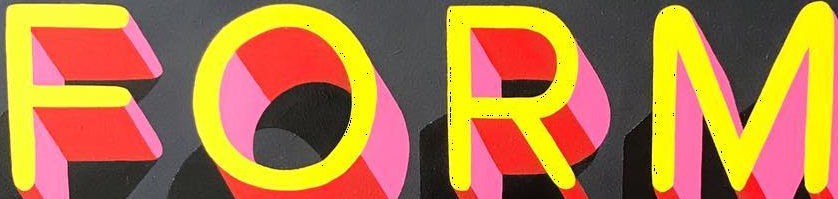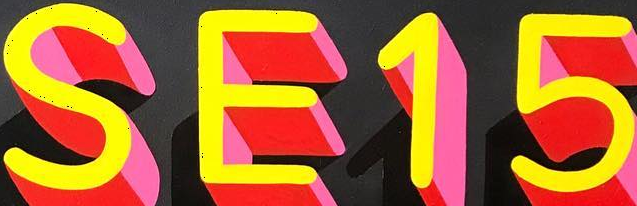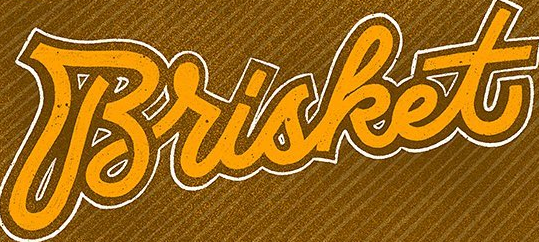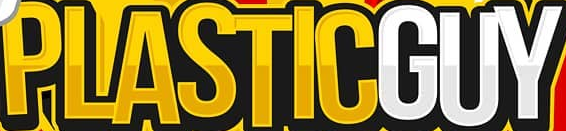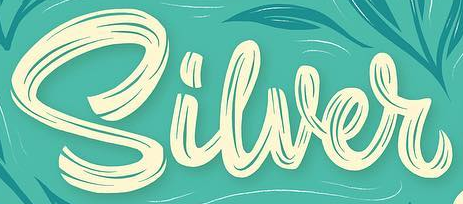What text is displayed in these images sequentially, separated by a semicolon? FORM; SE15; Brisket; PLASTICGUY; Siwer 